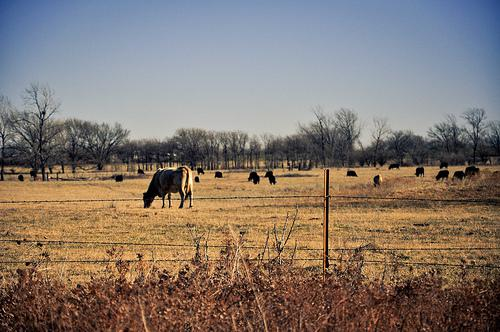Question: who is with the animals?
Choices:
A. They are alone.
B. The trainers.
C. The owners.
D. No one.
Answer with the letter. Answer: D Question: how many animals are there?
Choices:
A. Less than five.
B. More than two.
C. Less than six.
D. More than ten.
Answer with the letter. Answer: D Question: when was the photo taken?
Choices:
A. During the day.
B. Christmas.
C. Mothers Day.
D. Halloween.
Answer with the letter. Answer: A Question: what is in front of the camera?
Choices:
A. Rose.
B. Person.
C. A fence.
D. Bike.
Answer with the letter. Answer: C Question: what is in the background?
Choices:
A. Trees.
B. House.
C. Fence.
D. Man.
Answer with the letter. Answer: A Question: where are the animals?
Choices:
A. Behind the fence.
B. Zoo.
C. Park.
D. Forest.
Answer with the letter. Answer: A 